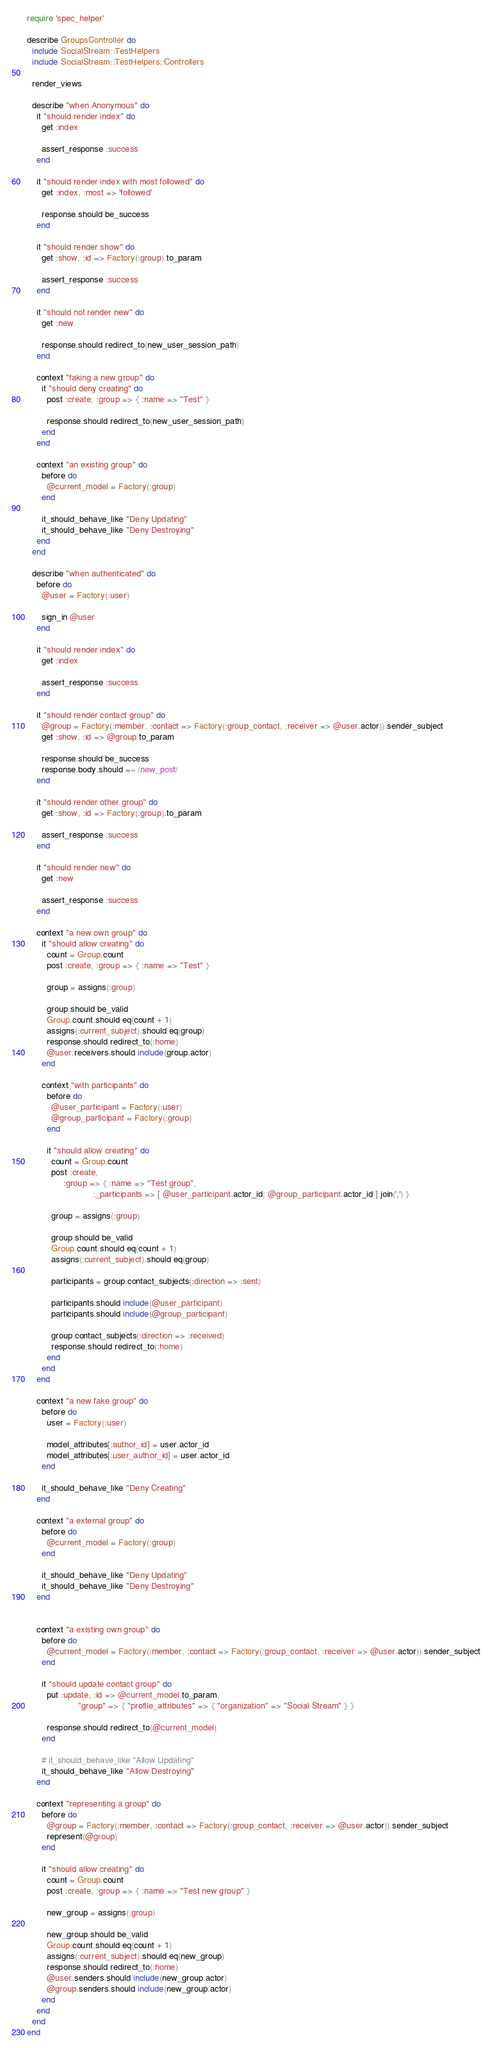<code> <loc_0><loc_0><loc_500><loc_500><_Ruby_>require 'spec_helper'

describe GroupsController do
  include SocialStream::TestHelpers
  include SocialStream::TestHelpers::Controllers

  render_views

  describe "when Anonymous" do
    it "should render index" do
      get :index

      assert_response :success
    end

    it "should render index with most followed" do
      get :index, :most => 'followed'

      response.should be_success
    end

    it "should render show" do
      get :show, :id => Factory(:group).to_param

      assert_response :success
    end

    it "should not render new" do
      get :new

      response.should redirect_to(new_user_session_path)
    end

    context "faking a new group" do
      it "should deny creating" do
        post :create, :group => { :name => "Test" }

        response.should redirect_to(new_user_session_path)
      end
    end

    context "an existing group" do
      before do
        @current_model = Factory(:group)
      end

      it_should_behave_like "Deny Updating"
      it_should_behave_like "Deny Destroying"
    end
  end

  describe "when authenticated" do
    before do
      @user = Factory(:user)

      sign_in @user
    end

    it "should render index" do
      get :index

      assert_response :success
    end

    it "should render contact group" do
      @group = Factory(:member, :contact => Factory(:group_contact, :receiver => @user.actor)).sender_subject
      get :show, :id => @group.to_param

      response.should be_success
      response.body.should =~ /new_post/
    end

    it "should render other group" do
      get :show, :id => Factory(:group).to_param

      assert_response :success
    end

    it "should render new" do
      get :new

      assert_response :success
    end

    context "a new own group" do
      it "should allow creating" do
        count = Group.count
        post :create, :group => { :name => "Test" }

        group = assigns(:group)

        group.should be_valid
        Group.count.should eq(count + 1)
        assigns(:current_subject).should eq(group)
        response.should redirect_to(:home)
        @user.receivers.should include(group.actor)
      end

      context "with participants" do
        before do
          @user_participant = Factory(:user)
          @group_participant = Factory(:group)
        end

        it "should allow creating" do
          count = Group.count
          post :create,
               :group => { :name => "Test group",
                           :_participants => [ @user_participant.actor_id, @group_participant.actor_id ].join(',') }

          group = assigns(:group)

          group.should be_valid
          Group.count.should eq(count + 1)
          assigns(:current_subject).should eq(group)

          participants = group.contact_subjects(:direction => :sent)

          participants.should include(@user_participant)
          participants.should include(@group_participant)

          group.contact_subjects(:direction => :received)
          response.should redirect_to(:home)
        end
      end
    end

    context "a new fake group" do
      before do
        user = Factory(:user)

        model_attributes[:author_id] = user.actor_id
        model_attributes[:user_author_id] = user.actor_id
      end

      it_should_behave_like "Deny Creating"
    end

    context "a external group" do
      before do
        @current_model = Factory(:group)
      end

      it_should_behave_like "Deny Updating"
      it_should_behave_like "Deny Destroying"
    end


    context "a existing own group" do
      before do
        @current_model = Factory(:member, :contact => Factory(:group_contact, :receiver => @user.actor)).sender_subject
      end

      it "should update contact group" do
        put :update, :id => @current_model.to_param,
                     "group" => { "profile_attributes" => { "organization" => "Social Stream" } }

        response.should redirect_to(@current_model)
      end

      # it_should_behave_like "Allow Updating"
      it_should_behave_like "Allow Destroying"
    end

    context "representing a group" do
      before do
        @group = Factory(:member, :contact => Factory(:group_contact, :receiver => @user.actor)).sender_subject
        represent(@group)
      end

      it "should allow creating" do
        count = Group.count
        post :create, :group => { :name => "Test new group" }

        new_group = assigns(:group)

        new_group.should be_valid
        Group.count.should eq(count + 1)
        assigns(:current_subject).should eq(new_group)
        response.should redirect_to(:home)
        @user.senders.should include(new_group.actor)
        @group.senders.should include(new_group.actor)
      end
    end
  end
end

</code> 